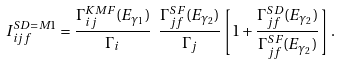Convert formula to latex. <formula><loc_0><loc_0><loc_500><loc_500>I ^ { { S D } = M 1 } _ { i j f } = \frac { \Gamma ^ { K M F } _ { i j } ( E _ { \gamma _ { 1 } } ) } { \Gamma _ { i } } \ \frac { \Gamma ^ { S F } _ { j f } ( E _ { \gamma _ { 2 } } ) } { \Gamma _ { j } } \left [ 1 + \frac { \Gamma ^ { S D } _ { j f } ( E _ { \gamma _ { 2 } } ) } { \Gamma ^ { S F } _ { j f } ( E _ { \gamma _ { 2 } } ) } \right ] .</formula> 